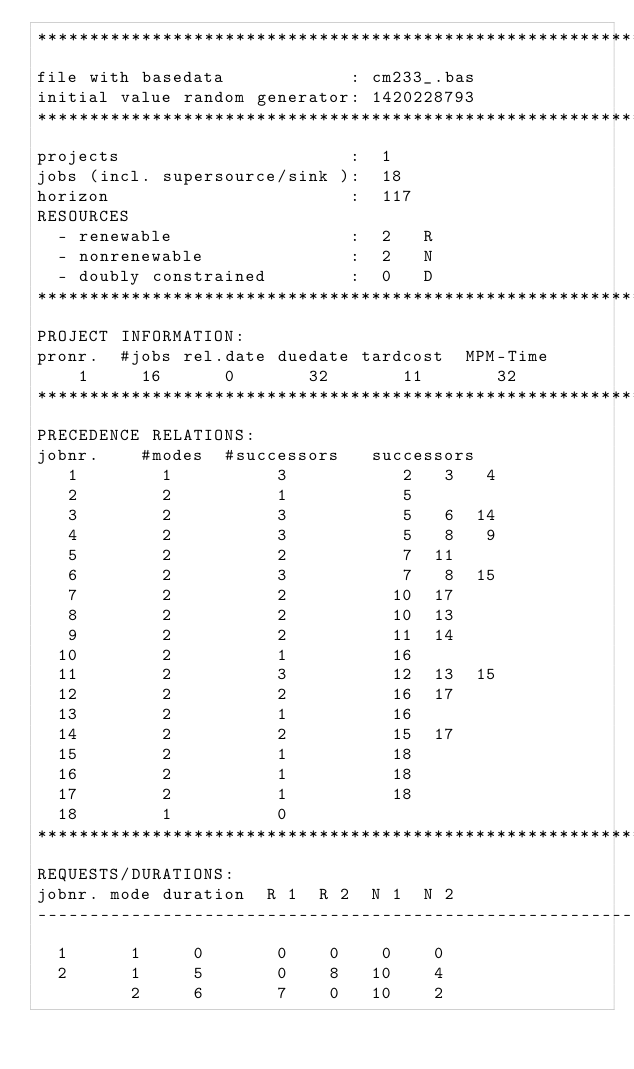Convert code to text. <code><loc_0><loc_0><loc_500><loc_500><_ObjectiveC_>************************************************************************
file with basedata            : cm233_.bas
initial value random generator: 1420228793
************************************************************************
projects                      :  1
jobs (incl. supersource/sink ):  18
horizon                       :  117
RESOURCES
  - renewable                 :  2   R
  - nonrenewable              :  2   N
  - doubly constrained        :  0   D
************************************************************************
PROJECT INFORMATION:
pronr.  #jobs rel.date duedate tardcost  MPM-Time
    1     16      0       32       11       32
************************************************************************
PRECEDENCE RELATIONS:
jobnr.    #modes  #successors   successors
   1        1          3           2   3   4
   2        2          1           5
   3        2          3           5   6  14
   4        2          3           5   8   9
   5        2          2           7  11
   6        2          3           7   8  15
   7        2          2          10  17
   8        2          2          10  13
   9        2          2          11  14
  10        2          1          16
  11        2          3          12  13  15
  12        2          2          16  17
  13        2          1          16
  14        2          2          15  17
  15        2          1          18
  16        2          1          18
  17        2          1          18
  18        1          0        
************************************************************************
REQUESTS/DURATIONS:
jobnr. mode duration  R 1  R 2  N 1  N 2
------------------------------------------------------------------------
  1      1     0       0    0    0    0
  2      1     5       0    8   10    4
         2     6       7    0   10    2</code> 